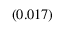<formula> <loc_0><loc_0><loc_500><loc_500>_ { ( 0 . 0 1 7 ) }</formula> 